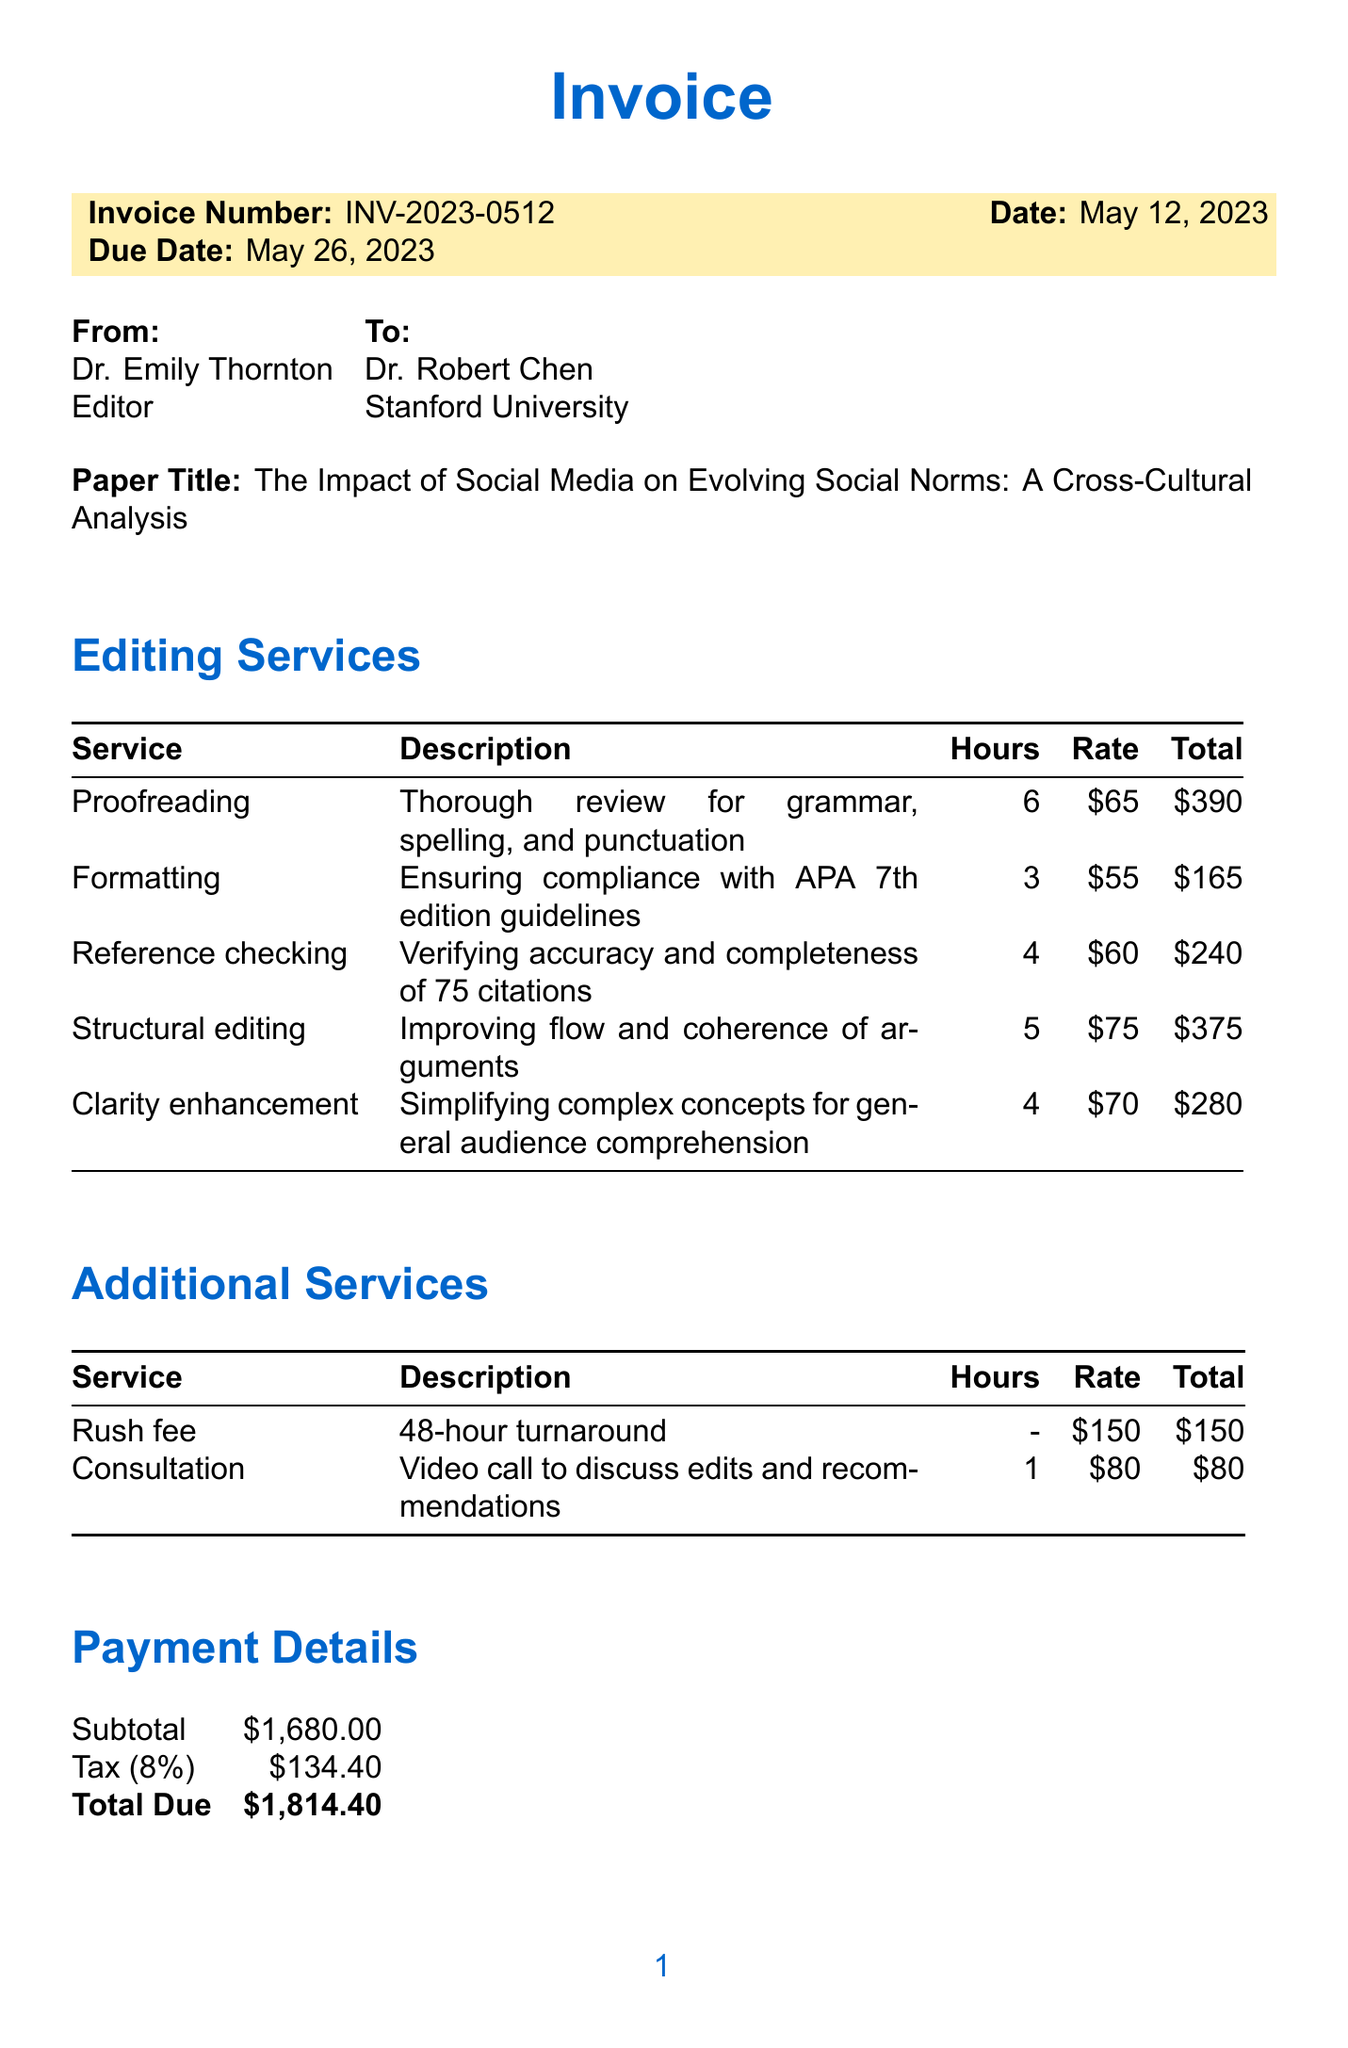What is the invoice number? The invoice number is listed at the top of the invoice document.
Answer: INV-2023-0512 Who is the client? The client's name is specified in the "To" section of the invoice.
Answer: Dr. Robert Chen, Stanford University What is the total due amount? The total due is calculated by summing the subtotal and tax outlined in the payment details.
Answer: $1814.40 How many hours were spent on proofreading? The number of hours for each service is detailed in the editing services table.
Answer: 6 What is the service rate for formatting? The rate per hour for formatting is specified in the editing services section.
Answer: $55 What additional service has a flat rate? One of the services does not charge by the hour but has a set fee instead.
Answer: Rush fee Name one publication recommendation. The recommendations for publication are listed at the end of the document.
Answer: Consider submitting a condensed version to The Atlantic for wider reach What tax rate is applied? The applicable tax rate is mentioned in the payment details.
Answer: 8% What type of editing service was conducted to improve the flow? The editing services include various types, logged in the services section of the document.
Answer: Structural editing 